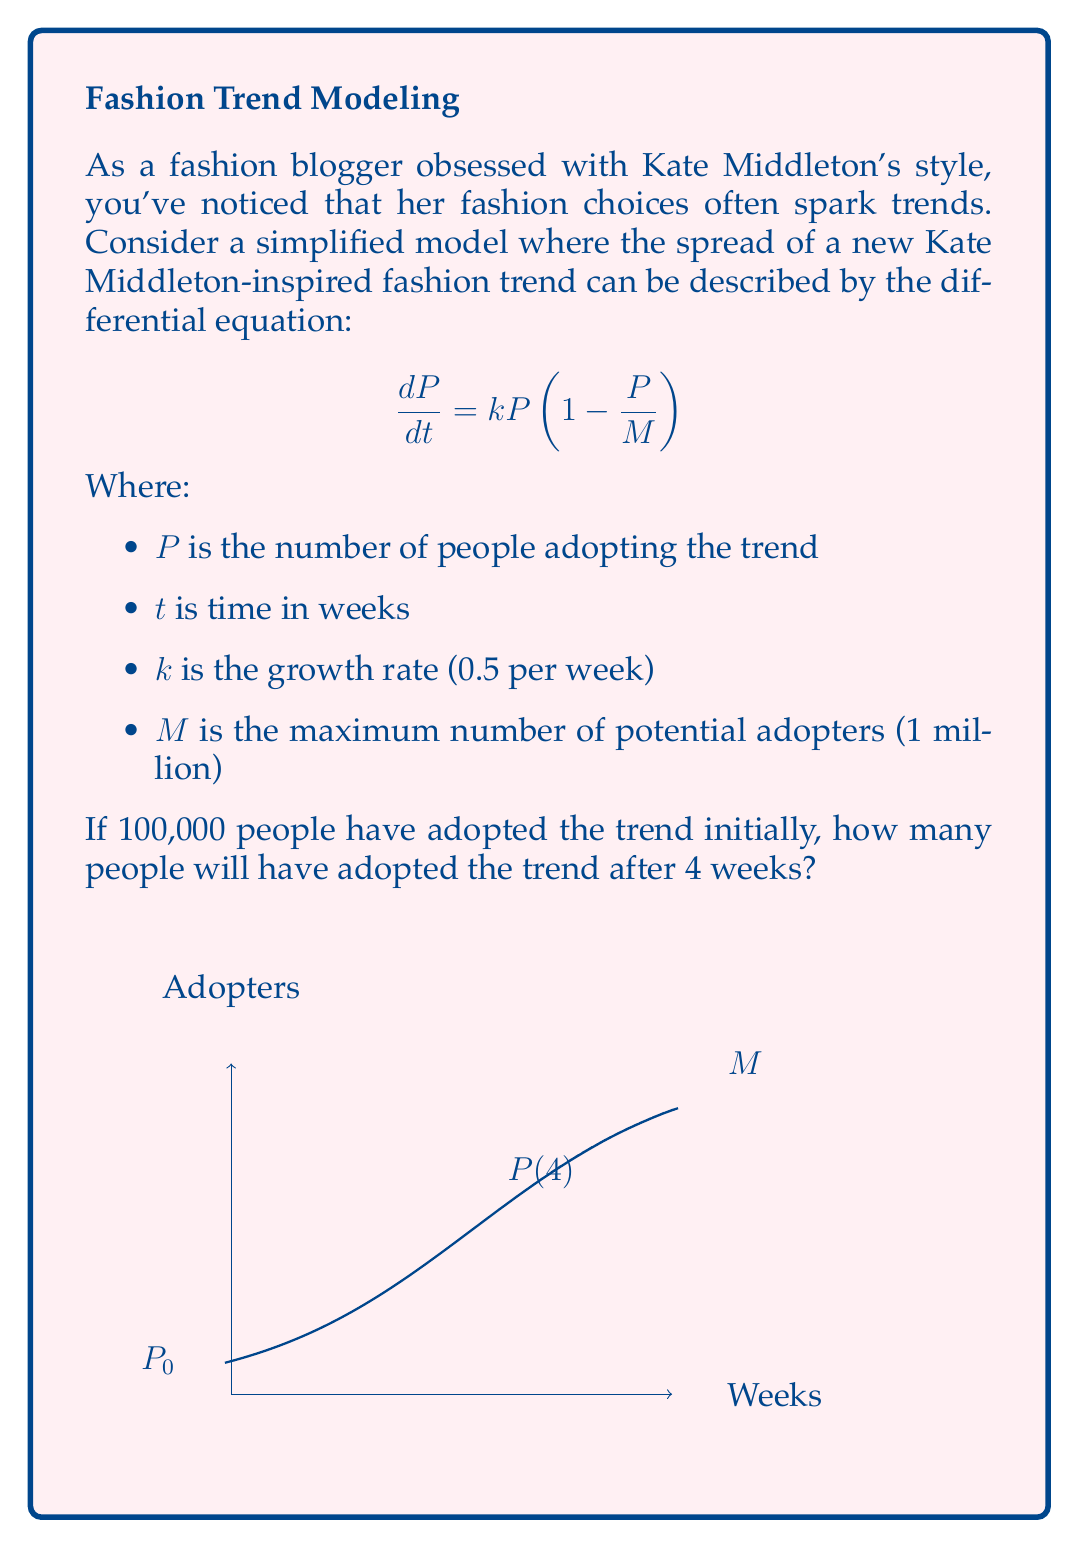What is the answer to this math problem? Let's solve this step-by-step using the logistic growth model:

1) The differential equation given is the logistic growth equation:
   $$\frac{dP}{dt} = kP(1-\frac{P}{M})$$

2) The solution to this equation is:
   $$P(t) = \frac{M}{1 + (\frac{M}{P_0} - 1)e^{-kt}}$$

   Where $P_0$ is the initial population.

3) We're given:
   - $k = 0.5$ per week
   - $M = 1,000,000$ people
   - $P_0 = 100,000$ people
   - $t = 4$ weeks

4) Let's substitute these values into our equation:
   $$P(4) = \frac{1,000,000}{1 + (\frac{1,000,000}{100,000} - 1)e^{-0.5 \cdot 4}}$$

5) Simplify:
   $$P(4) = \frac{1,000,000}{1 + (10 - 1)e^{-2}}$$
   $$P(4) = \frac{1,000,000}{1 + 9e^{-2}}$$

6) Calculate $e^{-2} \approx 0.1353$:
   $$P(4) = \frac{1,000,000}{1 + 9 \cdot 0.1353}$$
   $$P(4) = \frac{1,000,000}{1 + 1.2177}$$
   $$P(4) = \frac{1,000,000}{2.2177}$$

7) Finally:
   $$P(4) \approx 450,915$$

Therefore, after 4 weeks, approximately 450,915 people will have adopted the Kate Middleton-inspired fashion trend.
Answer: 450,915 people 